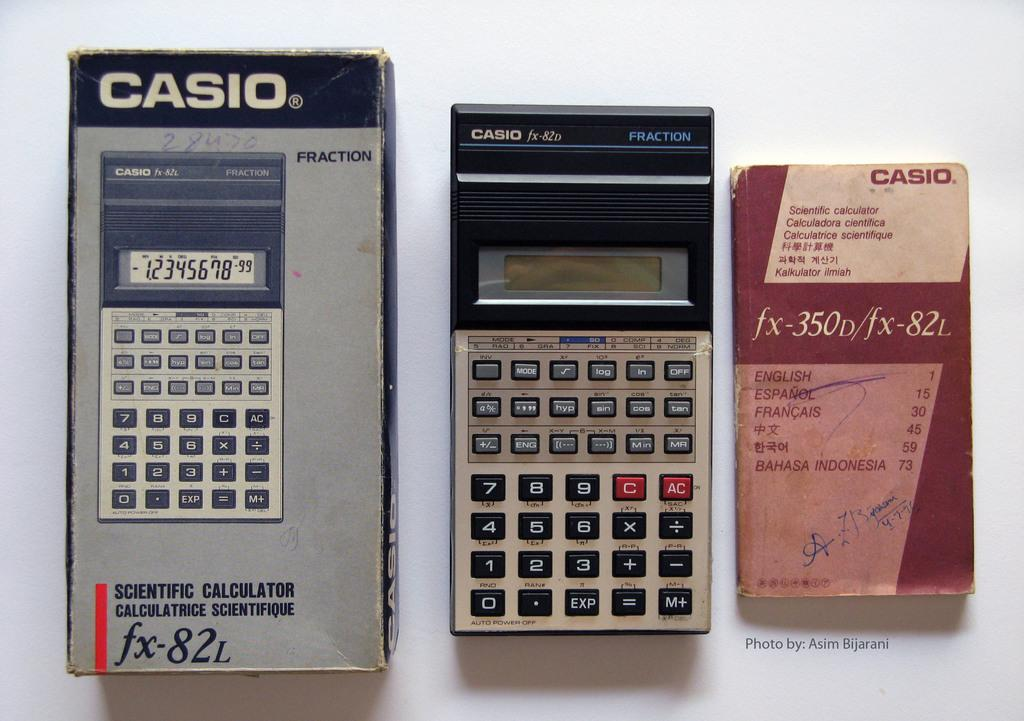<image>
Present a compact description of the photo's key features. A few casio items showcased from largest to smallest 